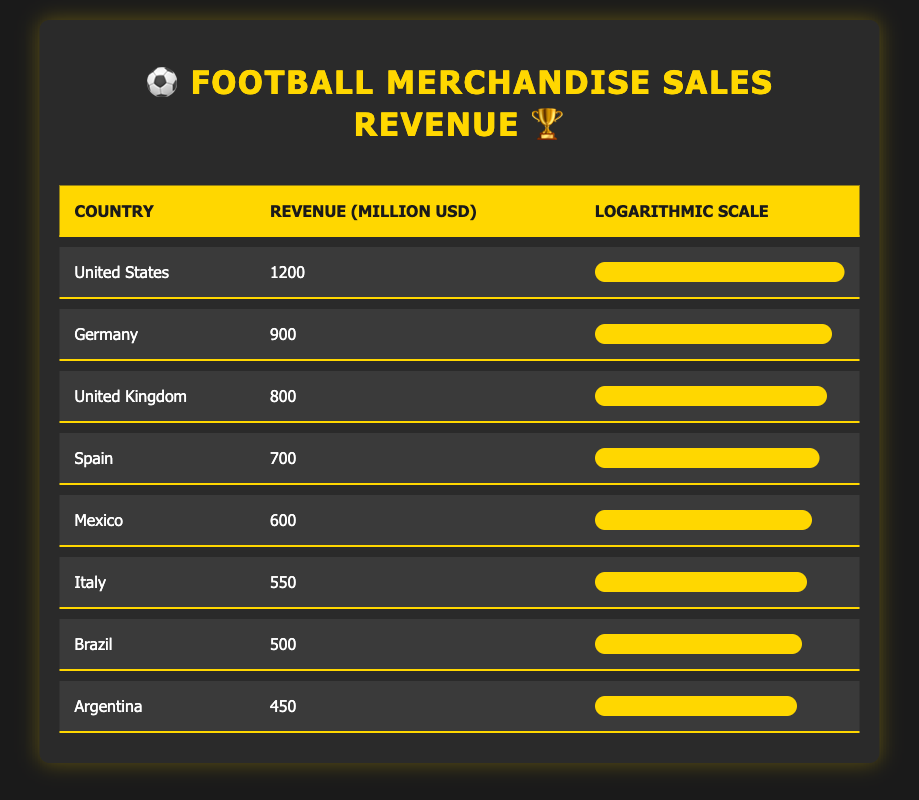What is the revenue from football merchandise sales in Mexico? According to the table, the revenue for Mexico is directly listed under the revenue column, which shows 600 million USD.
Answer: 600 million USD Which country has the highest revenue from football merchandise sales? The table clearly lists the revenue for each country, with the United States having the highest figure of 1200 million USD.
Answer: United States What is the average revenue from football merchandise sales of the top three countries? The top three countries by revenue are the United States (1200), Germany (900), and the United Kingdom (800). Summing these gives 1200 + 900 + 800 = 2900 million USD. Dividing by three provides the average: 2900 / 3 = 966.67 million USD.
Answer: 966.67 million USD Is Brazil's revenue from football merchandise sales higher than that of Argentina? Brazil has a revenue of 500 million USD, while Argentina's revenue is 450 million USD. Since 500 is greater than 450, this statement is true.
Answer: Yes What is the total revenue from football merchandise sales for Mexico, Brazil, and Argentina combined? Mexico has 600 million USD, Brazil has 500 million USD, and Argentina has 450 million USD. Adding these together: 600 + 500 + 450 = 1550 million USD.
Answer: 1550 million USD Which country has lower merchandise sales, Italy or Spain? Italy has a revenue of 550 million USD while Spain has 700 million USD. Since 550 is less than 700, Italy has lower sales.
Answer: Italy If we compare the revenue of Germany and the United Kingdom, what is the difference? Germany has revenue of 900 million USD and the United Kingdom has revenue of 800 million USD. The difference is 900 - 800 = 100 million USD.
Answer: 100 million USD What percentage of United States revenue does Mexico account for? Mexico's revenue is 600 million USD and the United States' revenue is 1200 million USD. To find the percentage, we calculate (600 / 1200) * 100 = 50%.
Answer: 50% 